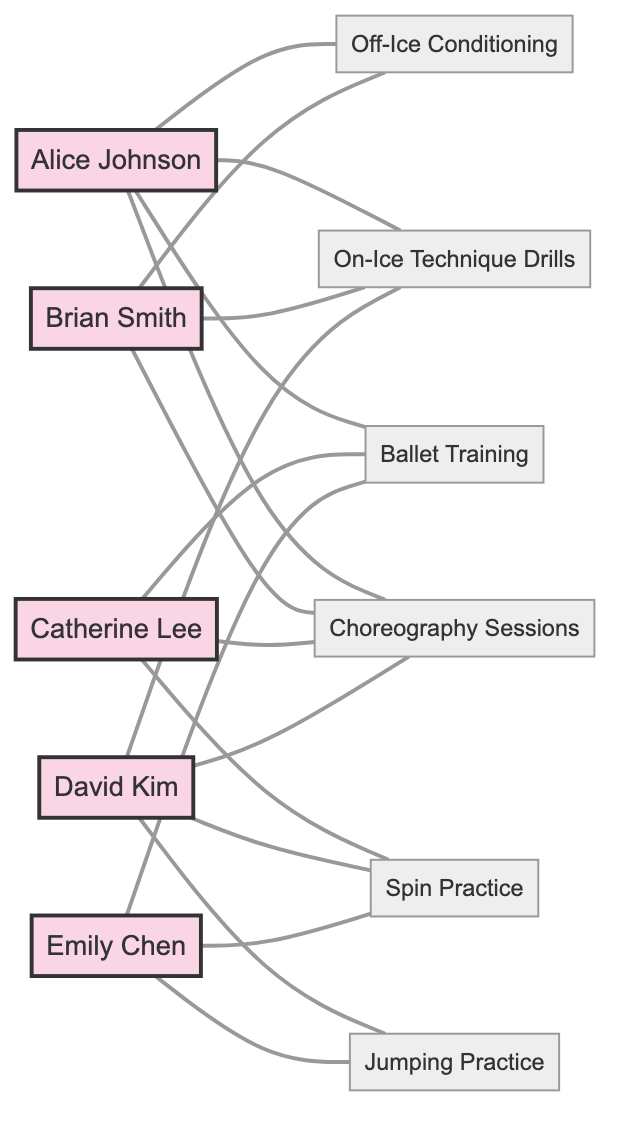What is the total number of athletes in the diagram? The diagram outlines five distinct athletes: Alice Johnson, Brian Smith, Catherine Lee, David Kim, and Emily Chen. By counting these names, we can confirm the total count as 5.
Answer: 5 Which activities does Alice Johnson share with Brian Smith? The diagram shows a connection between Alice Johnson and Brian Smith, with the shared activities listed as Off-Ice Conditioning and On-Ice Technique Drills. Thus, we can identify these two activities as the answer.
Answer: Off-Ice Conditioning, On-Ice Technique Drills How many activities are Alice Johnson and Catherine Lee training together? The relationship between Alice Johnson and Catherine Lee includes Ballet Training and Choreography Sessions, totaling 2 shared activities. By reviewing the connections, we confirm the number of shared activities.
Answer: 2 Who are the two athletes that share Jumping Practice? The connection between David Kim and Emily Chen reveals that they share the activity Jumping Practice. Therefore, these two athletes are the answer to the question.
Answer: David Kim, Emily Chen What is the shared activity between Brian Smith and David Kim? The diagram indicates a relationship between Brian Smith and David Kim with two shared activities: On-Ice Technique Drills and Choreography Sessions. Thus, we can state these shared activities as the answer.
Answer: On-Ice Technique Drills, Choreography Sessions How many total edges (relationships) does the diagram represent? By reviewing the relationships listed, there are 5 distinct pairs of athletes sharing activities: Alice and Brian, Alice and Catherine, David and Emily, Brian and David, and Catherine and Emily. Counting these pairs yields a total of 5 edges.
Answer: 5 Which activities does Catherine Lee share with Emily Chen? The relationship between Catherine Lee and Emily Chen indicates that they share Ballet Training and Spin Practice. Thus, these activities are the answer.
Answer: Ballet Training, Spin Practice Is there any athlete who shares all activities with another athlete? Upon reviewing the relationships, no athlete shares all activities with another athlete; each relationship contains specific shared activities, not all of them. Consequently, the answer is that no athlete shares all activities.
Answer: No What type of training does David Kim not share with Emily Chen? David Kim and Emily Chen share Jumping Practice and Spin Practice. The only other training activity that David Kim is involved in and is not shared with Emily Chen is On-Ice Technique Drills and Choreography Sessions. Hence, the answer must include these activities.
Answer: On-Ice Technique Drills, Choreography Sessions 